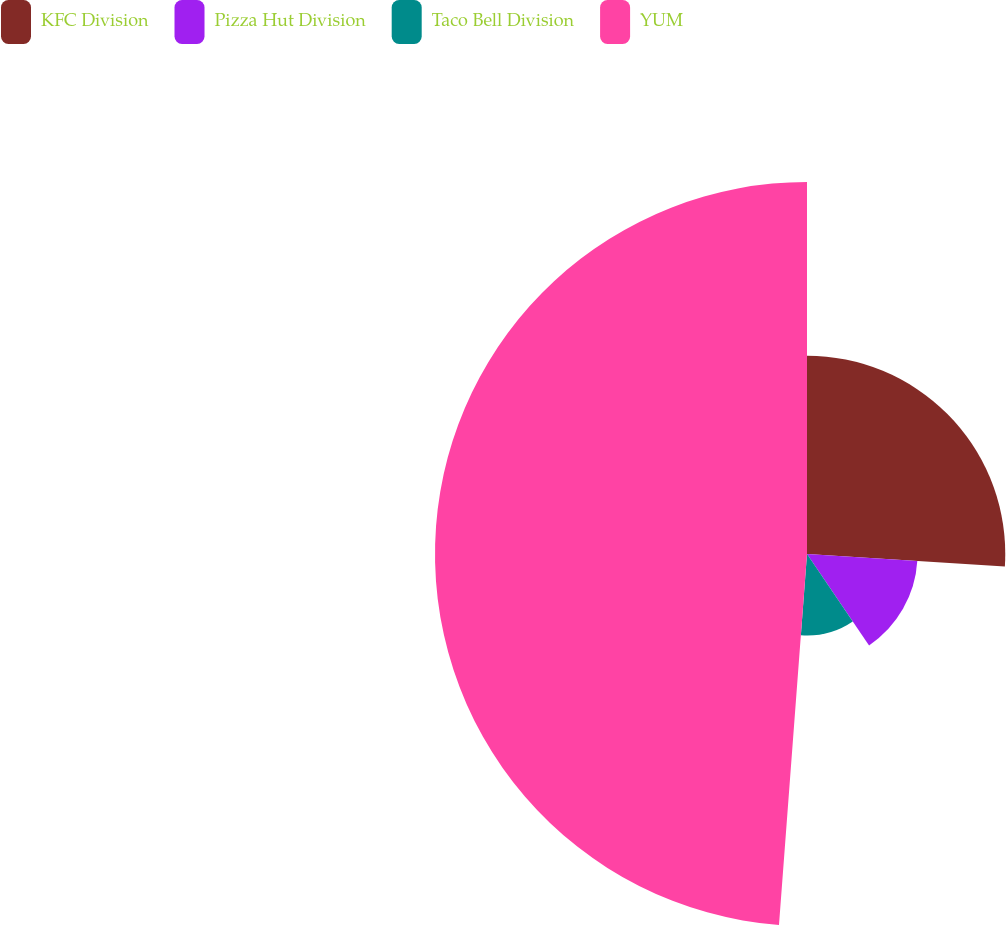<chart> <loc_0><loc_0><loc_500><loc_500><pie_chart><fcel>KFC Division<fcel>Pizza Hut Division<fcel>Taco Bell Division<fcel>YUM<nl><fcel>26.01%<fcel>14.5%<fcel>10.69%<fcel>48.8%<nl></chart> 